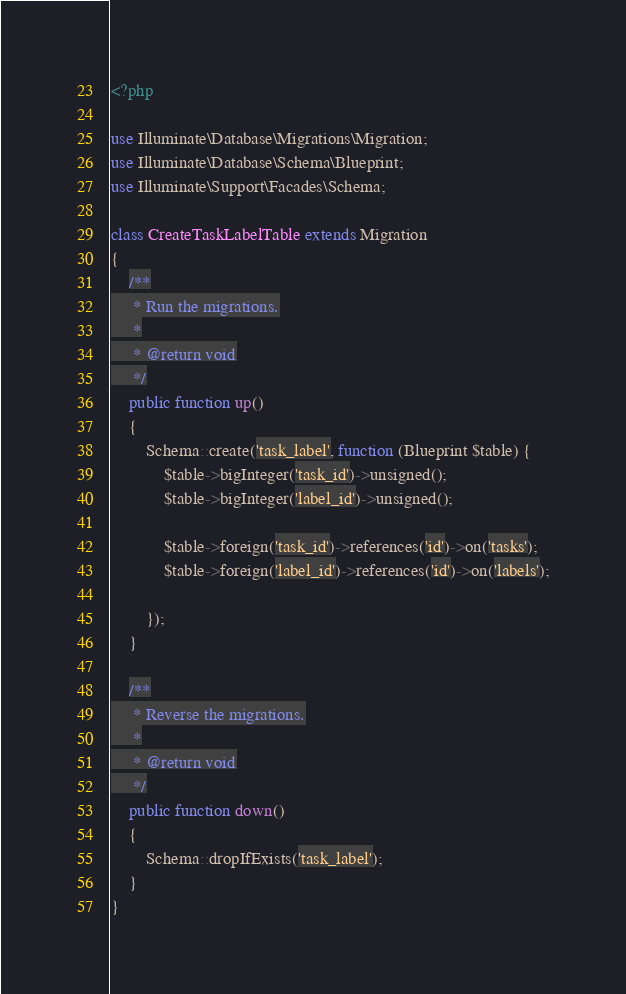Convert code to text. <code><loc_0><loc_0><loc_500><loc_500><_PHP_><?php

use Illuminate\Database\Migrations\Migration;
use Illuminate\Database\Schema\Blueprint;
use Illuminate\Support\Facades\Schema;

class CreateTaskLabelTable extends Migration
{
    /**
     * Run the migrations.
     *
     * @return void
     */
    public function up()
    {
        Schema::create('task_label', function (Blueprint $table) {
            $table->bigInteger('task_id')->unsigned();
            $table->bigInteger('label_id')->unsigned();

            $table->foreign('task_id')->references('id')->on('tasks');
            $table->foreign('label_id')->references('id')->on('labels');

        });
    }

    /**
     * Reverse the migrations.
     *
     * @return void
     */
    public function down()
    {
        Schema::dropIfExists('task_label');
    }
}
</code> 